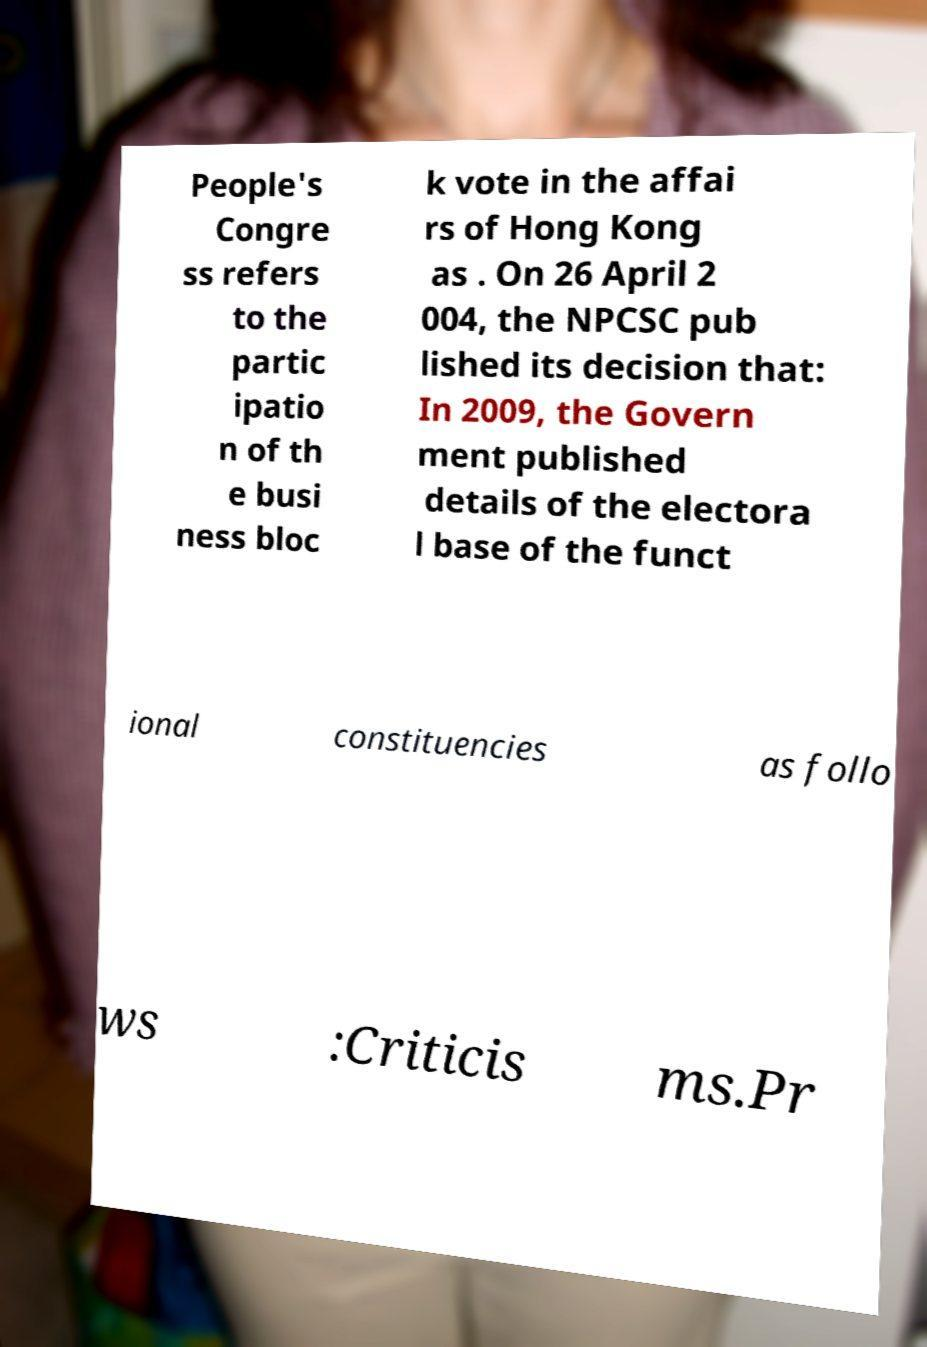I need the written content from this picture converted into text. Can you do that? People's Congre ss refers to the partic ipatio n of th e busi ness bloc k vote in the affai rs of Hong Kong as . On 26 April 2 004, the NPCSC pub lished its decision that: In 2009, the Govern ment published details of the electora l base of the funct ional constituencies as follo ws :Criticis ms.Pr 